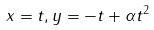<formula> <loc_0><loc_0><loc_500><loc_500>x = t , y = - t + \alpha t ^ { 2 }</formula> 